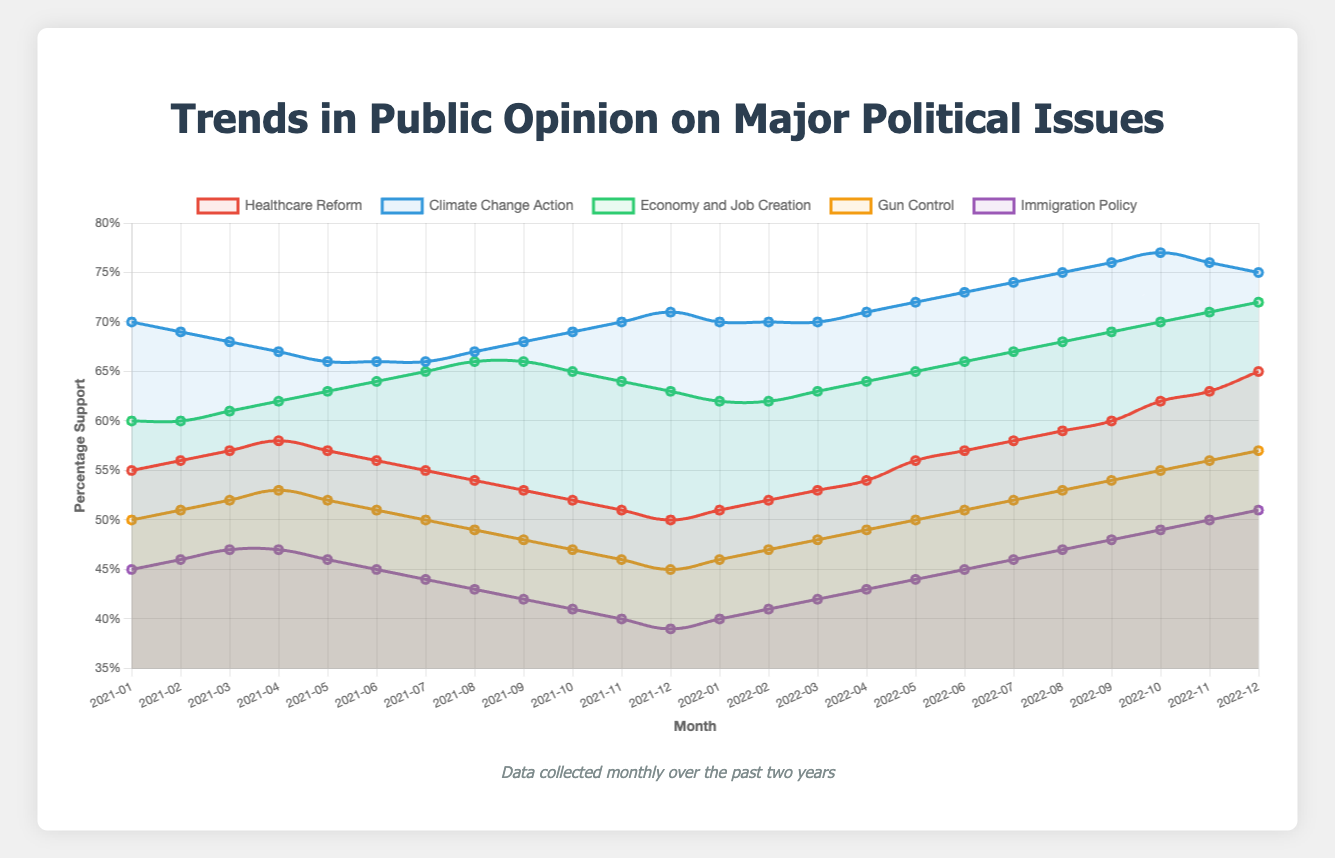Which political issue had the highest support at the start of the data collection? At the start of the data collection (January 2021), "Climate Change Action" had the highest support at 70%.
Answer: Climate Change Action Which political issue's support increased the most over the two-year period? Healthcare Reform started at 55% in January 2021 and ended at 65% in December 2022, an increase of 10%. This is the largest increase among all issues.
Answer: Healthcare Reform By how much did support for Gun Control change from its lowest point in 2021 to its highest point in 2022? The lowest support for Gun Control in 2021 was 45% in December. The highest support in 2022 was 57% in December. The change is 57% - 45% = 12%.
Answer: 12% Compare the support for Economy and Job Creation in March 2021 and March 2022. Which month had higher support and by how much? The support in March 2021 was 61%, and in March 2022, it was 63%. March 2022 had higher support by 63 - 61 = 2%.
Answer: March 2022 by 2% Calculate the average support for Immigration Policy in 2022. The monthly supports for Immigration Policy in 2022 are: 40, 41, 42, 43, 44, 45, 46, 47, 48, 49, 50, 51. Sum these values to get 546, and divide by 12 for the average: 546 / 12 ≈ 45.5%.
Answer: 45.5% Between which months did Healthcare Reform see the largest single-month increase in support? The largest single-month increase for Healthcare Reform was between November 2022 (63%) and December 2022 (65%), an increase of 2%.
Answer: November 2022 and December 2022 Which issue saw the most drastic decline in support at any point over the two-year period? Immigration Policy dropped from 45% in January 2021 to 39% in December 2021, the steepest decline of 6% over a year.
Answer: Immigration Policy What was the color of the line representing Climate Change Action? The line for Climate Change Action is represented by the color blue.
Answer: Blue How did the support for Gun Control and Immigration Policy in December 2022 compare? In December 2022, Gun Control had 57% support and Immigration Policy had 51% support. Gun Control had 6% more support.
Answer: Gun Control had 6% more support Which issue had the most stable support in 2021? Climate Change Action's support varied minimally from 70% in January to 71% in December, showing the most stability.
Answer: Climate Change Action 